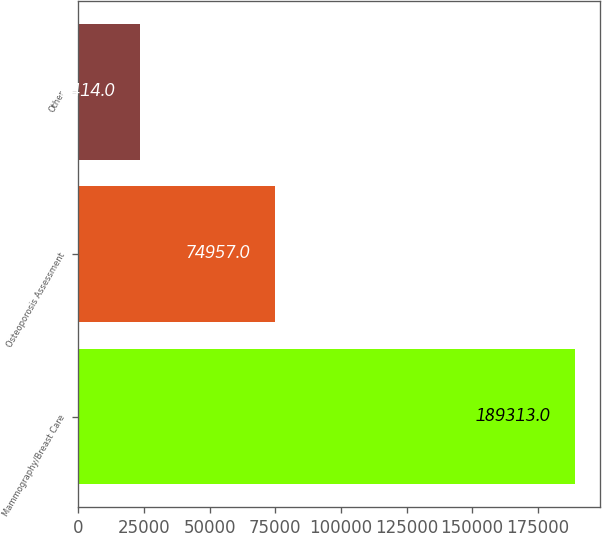<chart> <loc_0><loc_0><loc_500><loc_500><bar_chart><fcel>Mammography/Breast Care<fcel>Osteoporosis Assessment<fcel>Other<nl><fcel>189313<fcel>74957<fcel>23414<nl></chart> 